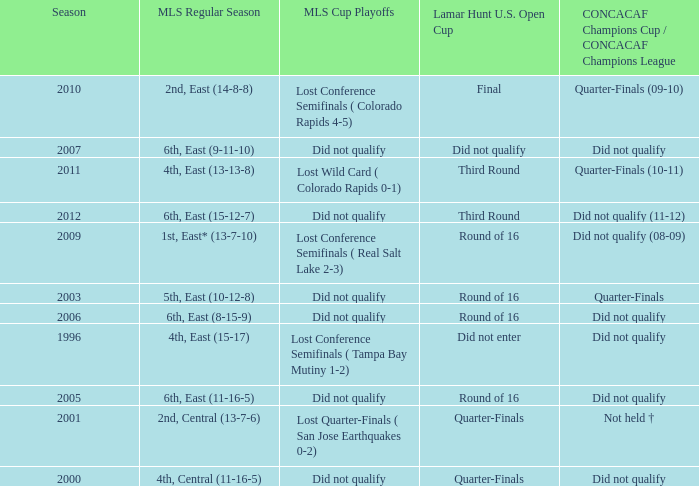What was the mls cup playoffs when concacaf champions cup / concacaf champions league was quarter-finals (09-10)? Lost Conference Semifinals ( Colorado Rapids 4-5). 